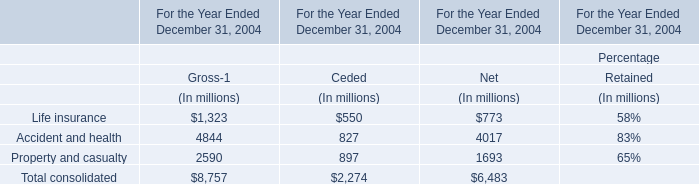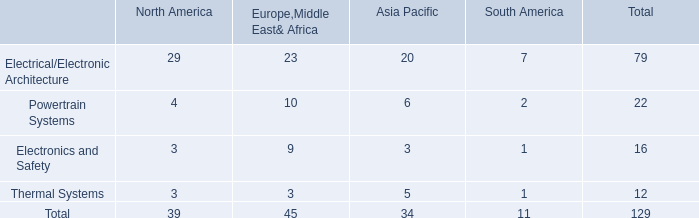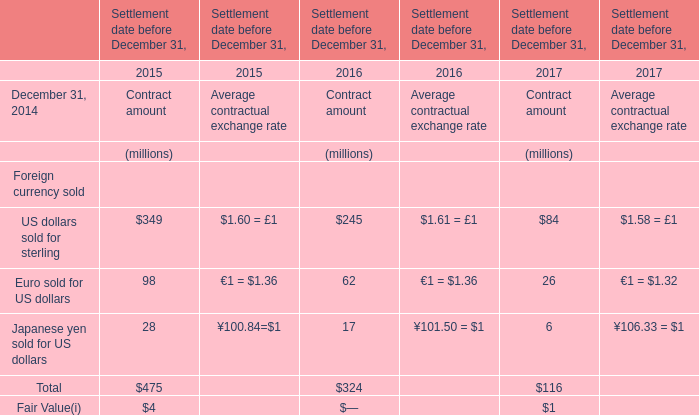What's the average of Contract amount in 2015? (in million) 
Computations: ((((349 + 98) + 28) + 4) / 4)
Answer: 119.75. 